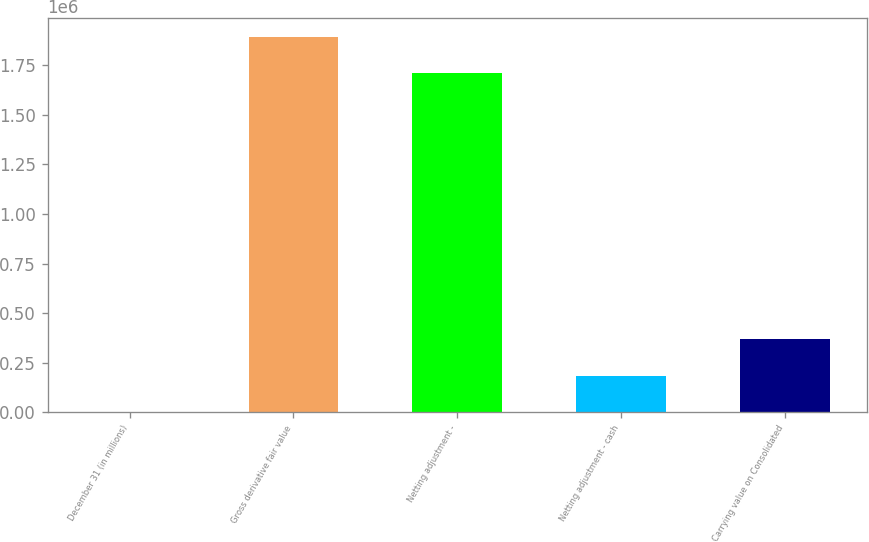Convert chart. <chart><loc_0><loc_0><loc_500><loc_500><bar_chart><fcel>December 31 (in millions)<fcel>Gross derivative fair value<fcel>Netting adjustment -<fcel>Netting adjustment - cash<fcel>Carrying value on Consolidated<nl><fcel>2011<fcel>1.89405e+06<fcel>1.71052e+06<fcel>185536<fcel>369060<nl></chart> 